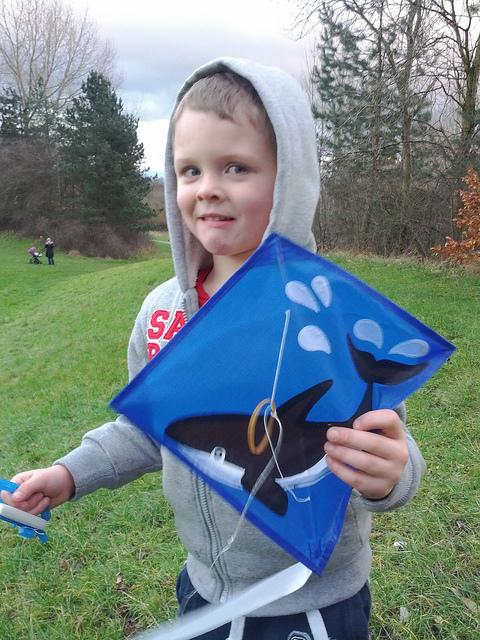What animal is on the kite? whale 